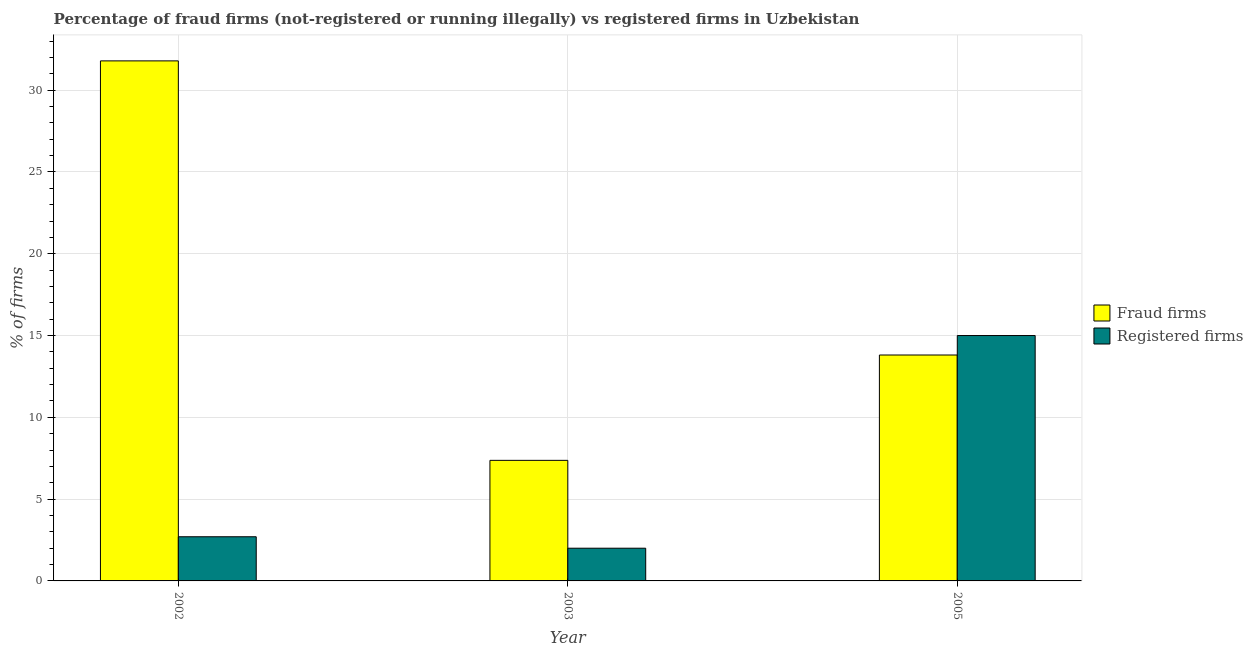What is the label of the 2nd group of bars from the left?
Your answer should be compact. 2003. What is the percentage of registered firms in 2003?
Your answer should be compact. 2. Across all years, what is the maximum percentage of fraud firms?
Your answer should be compact. 31.79. Across all years, what is the minimum percentage of fraud firms?
Offer a very short reply. 7.37. In which year was the percentage of registered firms maximum?
Keep it short and to the point. 2005. In which year was the percentage of registered firms minimum?
Ensure brevity in your answer.  2003. What is the total percentage of fraud firms in the graph?
Keep it short and to the point. 52.97. What is the difference between the percentage of registered firms in 2002 and that in 2003?
Your response must be concise. 0.7. What is the average percentage of fraud firms per year?
Make the answer very short. 17.66. In how many years, is the percentage of fraud firms greater than 24 %?
Your answer should be very brief. 1. What is the ratio of the percentage of fraud firms in 2002 to that in 2003?
Your response must be concise. 4.31. Is the percentage of fraud firms in 2002 less than that in 2005?
Offer a very short reply. No. What is the difference between the highest and the lowest percentage of fraud firms?
Your response must be concise. 24.42. In how many years, is the percentage of registered firms greater than the average percentage of registered firms taken over all years?
Your response must be concise. 1. What does the 1st bar from the left in 2002 represents?
Give a very brief answer. Fraud firms. What does the 1st bar from the right in 2003 represents?
Your response must be concise. Registered firms. How many bars are there?
Offer a very short reply. 6. What is the difference between two consecutive major ticks on the Y-axis?
Make the answer very short. 5. How many legend labels are there?
Make the answer very short. 2. What is the title of the graph?
Your answer should be compact. Percentage of fraud firms (not-registered or running illegally) vs registered firms in Uzbekistan. Does "Not attending school" appear as one of the legend labels in the graph?
Provide a short and direct response. No. What is the label or title of the Y-axis?
Keep it short and to the point. % of firms. What is the % of firms in Fraud firms in 2002?
Make the answer very short. 31.79. What is the % of firms in Fraud firms in 2003?
Ensure brevity in your answer.  7.37. What is the % of firms in Registered firms in 2003?
Your answer should be very brief. 2. What is the % of firms in Fraud firms in 2005?
Provide a succinct answer. 13.81. What is the % of firms of Registered firms in 2005?
Your answer should be compact. 15. Across all years, what is the maximum % of firms of Fraud firms?
Your answer should be compact. 31.79. Across all years, what is the maximum % of firms in Registered firms?
Your response must be concise. 15. Across all years, what is the minimum % of firms in Fraud firms?
Your response must be concise. 7.37. Across all years, what is the minimum % of firms of Registered firms?
Offer a terse response. 2. What is the total % of firms in Fraud firms in the graph?
Provide a short and direct response. 52.97. What is the total % of firms in Registered firms in the graph?
Your response must be concise. 19.7. What is the difference between the % of firms of Fraud firms in 2002 and that in 2003?
Give a very brief answer. 24.42. What is the difference between the % of firms of Registered firms in 2002 and that in 2003?
Your answer should be compact. 0.7. What is the difference between the % of firms of Fraud firms in 2002 and that in 2005?
Your answer should be very brief. 17.98. What is the difference between the % of firms in Registered firms in 2002 and that in 2005?
Provide a succinct answer. -12.3. What is the difference between the % of firms in Fraud firms in 2003 and that in 2005?
Ensure brevity in your answer.  -6.44. What is the difference between the % of firms in Fraud firms in 2002 and the % of firms in Registered firms in 2003?
Your response must be concise. 29.79. What is the difference between the % of firms of Fraud firms in 2002 and the % of firms of Registered firms in 2005?
Make the answer very short. 16.79. What is the difference between the % of firms in Fraud firms in 2003 and the % of firms in Registered firms in 2005?
Provide a succinct answer. -7.63. What is the average % of firms of Fraud firms per year?
Make the answer very short. 17.66. What is the average % of firms of Registered firms per year?
Provide a short and direct response. 6.57. In the year 2002, what is the difference between the % of firms of Fraud firms and % of firms of Registered firms?
Your response must be concise. 29.09. In the year 2003, what is the difference between the % of firms in Fraud firms and % of firms in Registered firms?
Your answer should be compact. 5.37. In the year 2005, what is the difference between the % of firms in Fraud firms and % of firms in Registered firms?
Offer a very short reply. -1.19. What is the ratio of the % of firms of Fraud firms in 2002 to that in 2003?
Your answer should be compact. 4.31. What is the ratio of the % of firms in Registered firms in 2002 to that in 2003?
Your response must be concise. 1.35. What is the ratio of the % of firms in Fraud firms in 2002 to that in 2005?
Make the answer very short. 2.3. What is the ratio of the % of firms of Registered firms in 2002 to that in 2005?
Your response must be concise. 0.18. What is the ratio of the % of firms in Fraud firms in 2003 to that in 2005?
Offer a very short reply. 0.53. What is the ratio of the % of firms of Registered firms in 2003 to that in 2005?
Offer a terse response. 0.13. What is the difference between the highest and the second highest % of firms of Fraud firms?
Offer a very short reply. 17.98. What is the difference between the highest and the second highest % of firms in Registered firms?
Give a very brief answer. 12.3. What is the difference between the highest and the lowest % of firms in Fraud firms?
Keep it short and to the point. 24.42. What is the difference between the highest and the lowest % of firms of Registered firms?
Your answer should be very brief. 13. 